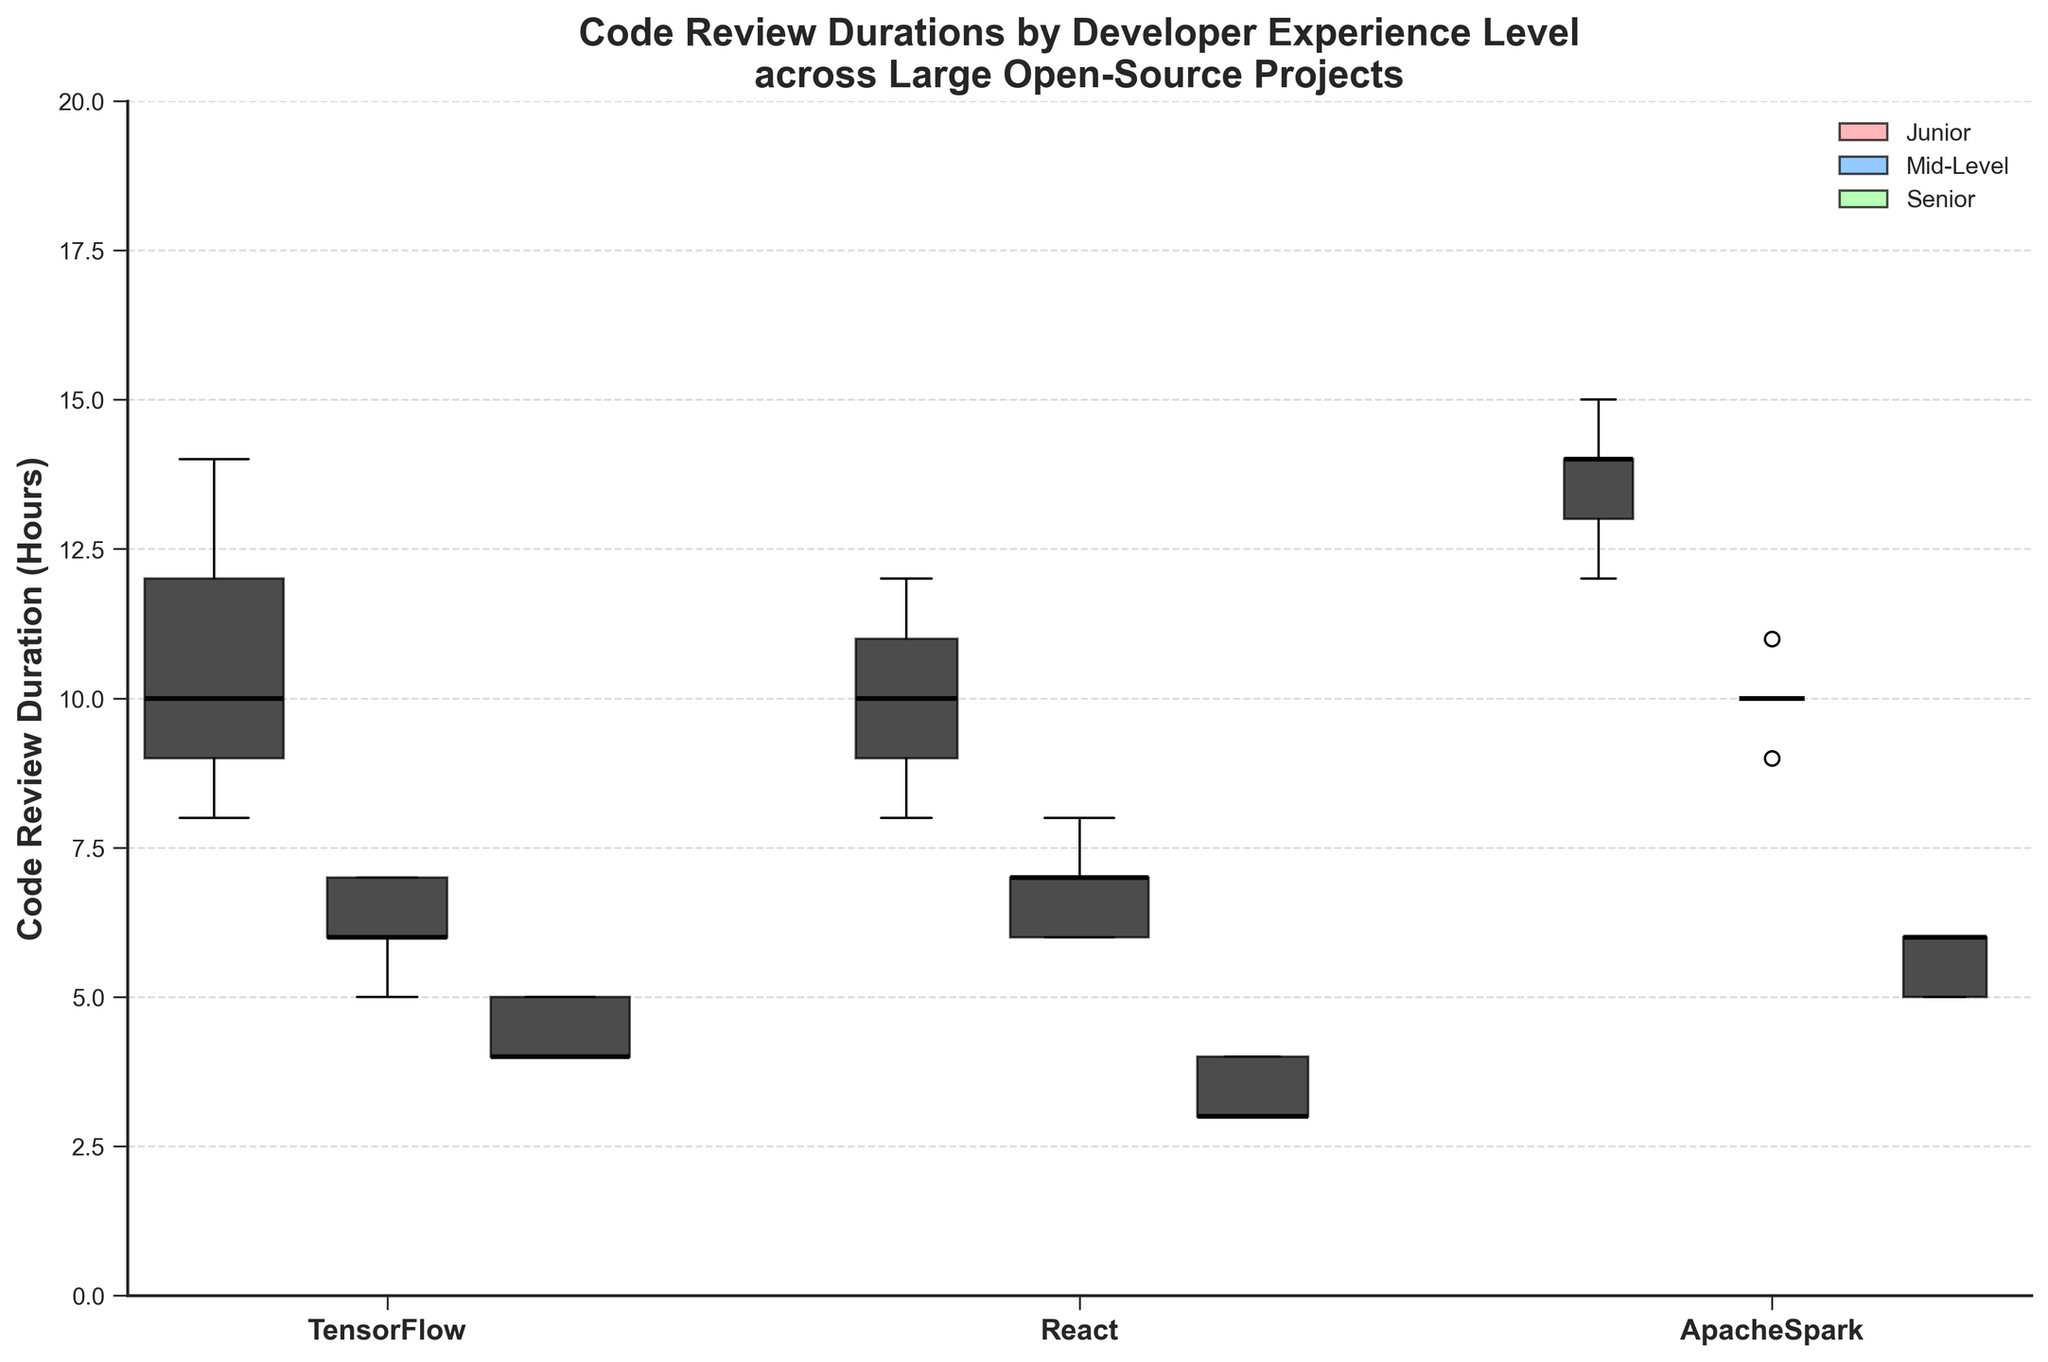What is the title of the plot? The title is prominently displayed at the top of the plot. It says "Code Review Durations by Developer Experience Level across Large Open-Source Projects".
Answer: Code Review Durations by Developer Experience Level across Large Open-Source Projects How is the color used to differentiate the developer experience levels? Each developer experience level is represented by a different color: Junior is in red, Mid-Level is in blue, and Senior is in green. This distinction is visible in the legend on the top right of the plot.
Answer: Red for Junior, Blue for Mid-Level, Green for Senior Which project has the most variable code review duration for Junior developers? By examining the width of the boxes for Junior developers (red color), TensorFlow has the widest box, indicating the most variable code review durations.
Answer: TensorFlow What is the median code review duration for Senior developers in the React project? In the box plots for Senior developers (green color) on the React project, the median (black line in the box) is at 3 hours.
Answer: 3 hours How do the code review durations for Mid-Level developers compare between TensorFlow and React projects? Comparing the blue boxes for TensorFlow and React projects, the medians for Mid-Level developers appear quite similar, both around 6 to 7 hours. However, the box for React is slightly wider, indicating more variation.
Answer: Similar, around 6 to 7 hours What is the general trend in code review duration as developer experience increases? As developer experience increases (from Junior to Senior), the median code review duration generally decreases across all projects. This can be observed by looking at the black median lines in the box plots that shift downward from Junior to Senior.
Answer: Decreases What project has the shortest median code review duration and for which experience level? By scanning the medians (black lines) across all plots, the shortest median code review duration is found in the React project for Senior developers, at around 3 hours.
Answer: React, Senior How does the variation in code review duration for Mid-Level developers in ApacheSpark compare to TensorFlow? The width of the boxes for Mid-Level developers in both projects indicates the variation. ApacheSpark has a narrower box compared to TensorFlow, suggesting less variation in code review durations for ApacheSpark.
Answer: Less variation in ApacheSpark Which project sees the largest number of code reviews for Junior developers? By looking at the width of the boxes (which signifies the number of reviews), the TensorFlow project has the widest red box for Junior developers, indicating it has the largest number of code reviews.
Answer: TensorFlow What is the range of code review durations for Senior developers in the ApacheSpark project? The range is determined by the ends of the whiskers in the box plot for Senior developers in ApacheSpark. The lower whisker is at 5 hours, and the upper whisker is at 6 hours, indicating a range of 1 hour.
Answer: 5 to 6 hours 